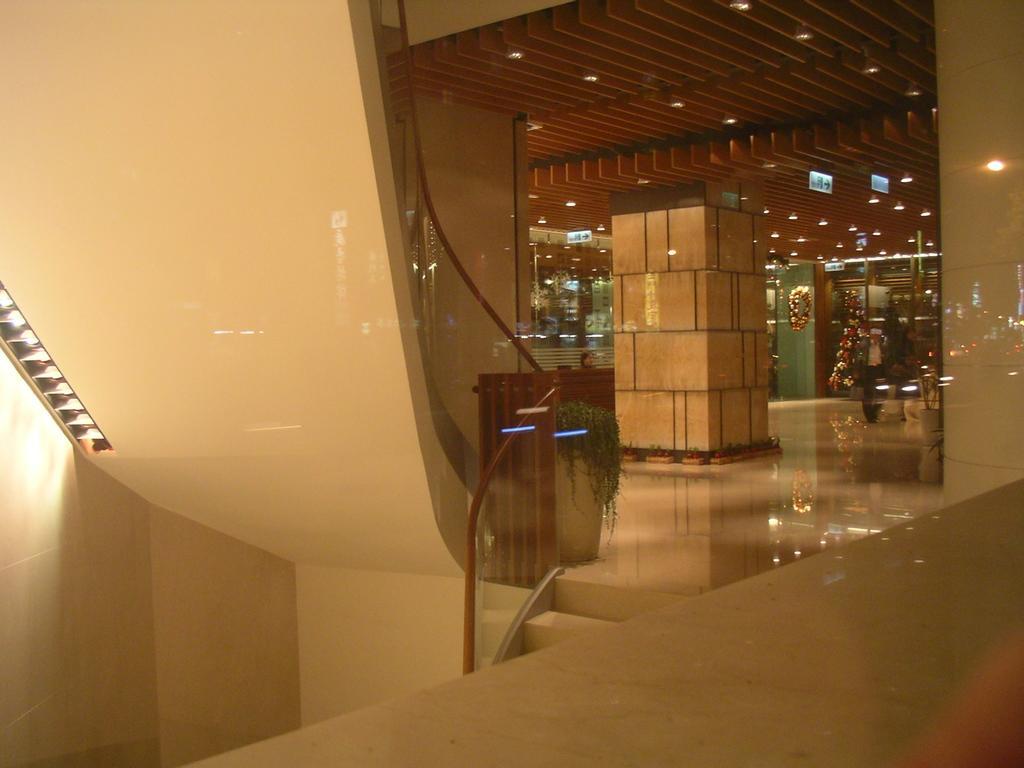Could you give a brief overview of what you see in this image? In this image I can see the inner part of the building and I can see few pillars, lights, few decorative items and I can also see few glass doors. In front I can see few stairs and the glass railing. 